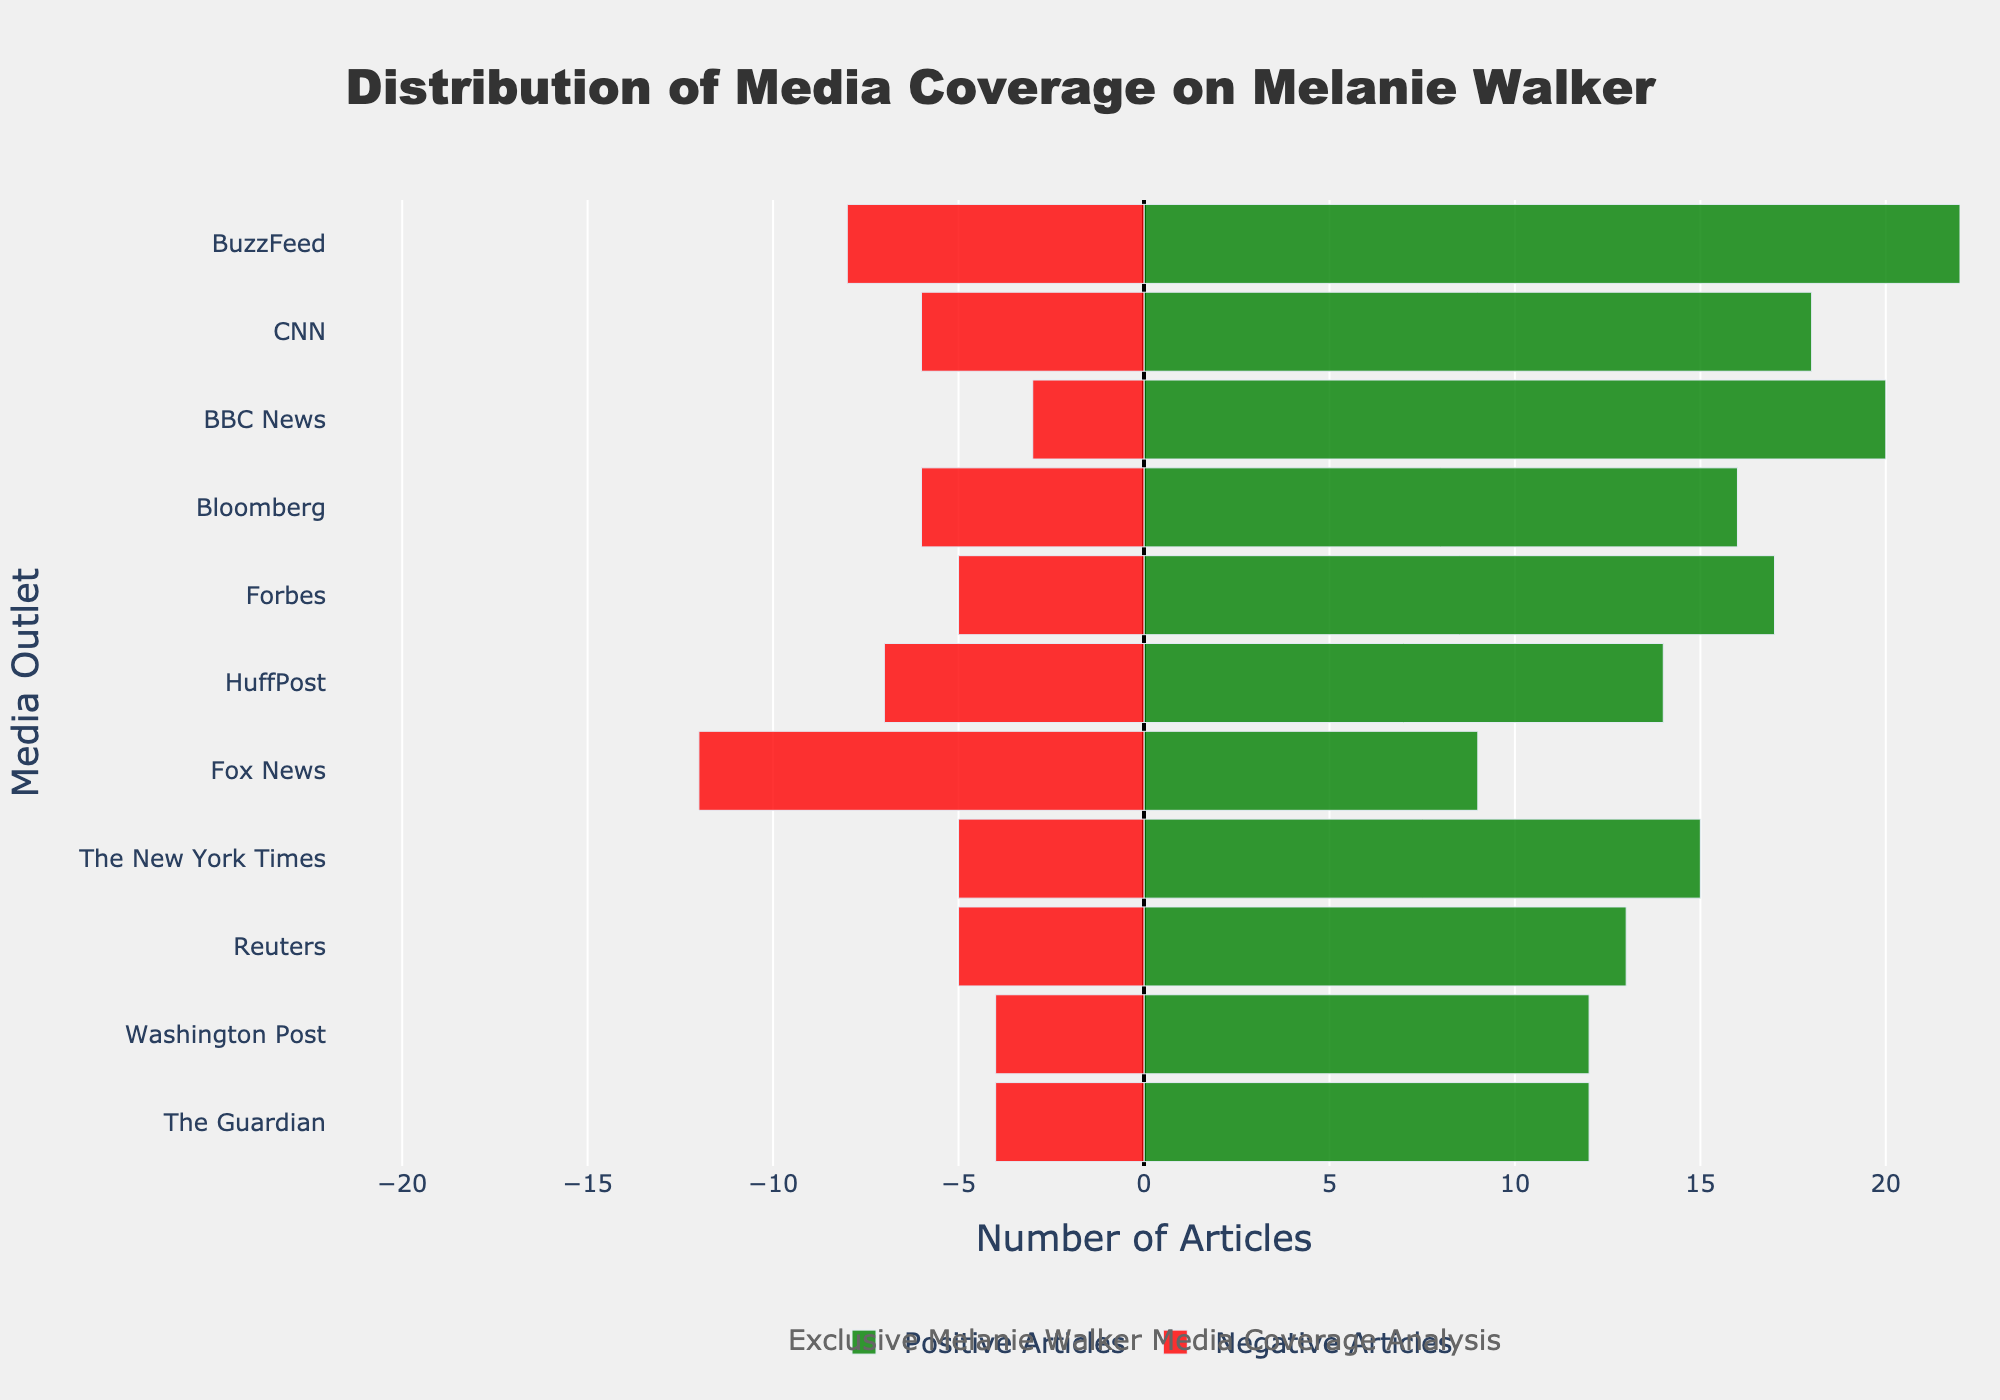Which media outlet had the highest number of positive articles? The green bars represent positive articles. BuzzFeed has the highest green bar, indicating it had the highest number of positive articles.
Answer: BuzzFeed Which media outlet had the highest number of negative articles? The red bars represent negative articles. Fox News has the longest red bar, indicating it had the highest number of negative articles.
Answer: Fox News How many more positive articles did BBC News have compared to Fox News? BBC News had 20 positive articles and Fox News had 9. The difference is 20 - 9 = 11.
Answer: 11 Which media outlets had an equal number of positive and negative articles as The Guardian? The Guardian had 12 positive and 4 negative articles. Look for other media outlets with the same count. Washington Post had 12 positive and 4 negative articles, matching The Guardian.
Answer: Washington Post What is the total number of articles (positive + negative) by CNN? Sum the positive and negative articles for CNN. Positive: 18, Negative: 6. Total = 18 + 6 = 24.
Answer: 24 Which media outlet showed the most balanced coverage (i.e., smallest difference between positive and negative articles)? Calculate the absolute difference between positive and negative articles for each outlet. The smallest difference is for Reuters (13 positive - 5 negative = 8).
Answer: Reuters Which media outlet had the lowest total number of articles? The total number of articles is the sum of positive and negative articles for each media outlet. The New York Times has the lowest total of 15 positive + 5 negative = 20 articles.
Answer: The New York Times Which three media outlets had the highest ratio of positive to negative articles? Calculate the ratio of positive to negative articles for each outlet and compare. BBC News (20/3 ≈ 6.67), The New York Times (15/5 = 3), and Forbes (17/5 = 3.4) have the highest ratios.
Answer: BBC News, Forbes, The New York Times How many total positive and negative articles are there across all media outlets? Sum all positive and negative articles respectively. Positive: 15 + 12 + 18 + 20 + 9 + 14 + 17 + 16 + 13 + 12 + 22 = 168. Negative: 5 + 4 + 6 + 3 + 12 + 7 + 5 + 6 + 5 + 4 + 8 = 65.
Answer: Positive: 168, Negative: 65 On average, how many negative articles were published per media outlet? Sum the negative articles and divide by the number of outlets. Sum of negatives: 65. Number of outlets: 11. Average = 65 / 11 ≈ 5.91.
Answer: ~5.91 